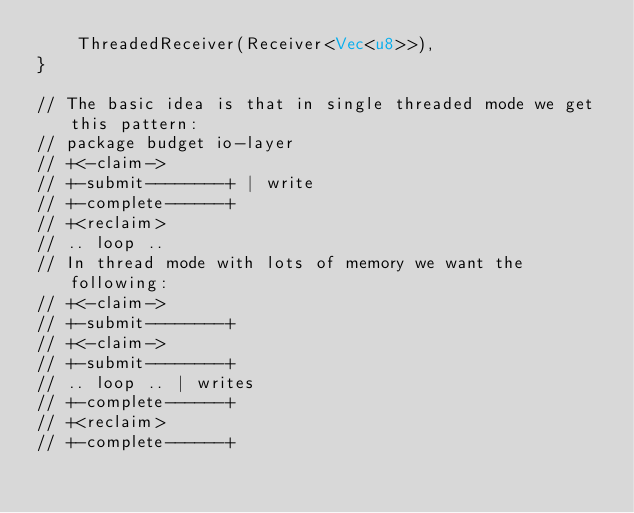<code> <loc_0><loc_0><loc_500><loc_500><_Rust_>    ThreadedReceiver(Receiver<Vec<u8>>),
}

// The basic idea is that in single threaded mode we get this pattern:
// package budget io-layer
// +<-claim->
// +-submit--------+ | write
// +-complete------+
// +<reclaim>
// .. loop ..
// In thread mode with lots of memory we want the following:
// +<-claim->
// +-submit--------+
// +<-claim->
// +-submit--------+
// .. loop .. | writes
// +-complete------+
// +<reclaim>
// +-complete------+</code> 